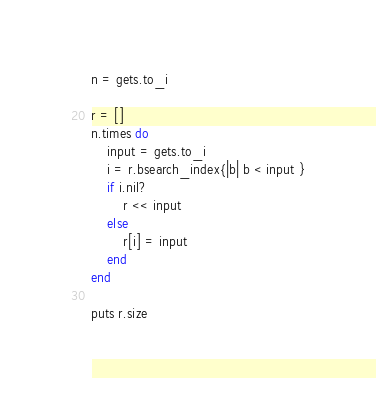Convert code to text. <code><loc_0><loc_0><loc_500><loc_500><_Ruby_>n = gets.to_i

r = []
n.times do
    input = gets.to_i
    i = r.bsearch_index{|b| b < input }
    if i.nil?
        r << input
    else
        r[i] = input
    end
end

puts r.size</code> 